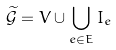Convert formula to latex. <formula><loc_0><loc_0><loc_500><loc_500>\widetilde { \mathcal { G } } = V \cup \bigcup _ { e \in E } I _ { e }</formula> 